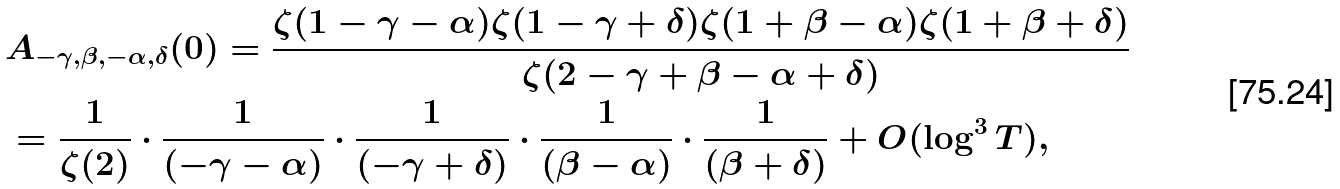Convert formula to latex. <formula><loc_0><loc_0><loc_500><loc_500>& A _ { - \gamma , \beta , - \alpha , \delta } ( 0 ) = \frac { \zeta ( 1 - \gamma - \alpha ) \zeta ( 1 - \gamma + \delta ) \zeta ( 1 + \beta - \alpha ) \zeta ( 1 + \beta + \delta ) } { \zeta ( 2 - \gamma + \beta - \alpha + \delta ) } \\ & = \frac { 1 } { \zeta ( 2 ) } \cdot \frac { 1 } { ( - \gamma - \alpha ) } \cdot \frac { 1 } { ( - \gamma + \delta ) } \cdot \frac { 1 } { ( \beta - \alpha ) } \cdot \frac { 1 } { ( \beta + \delta ) } + O ( \log ^ { 3 } { T } ) ,</formula> 